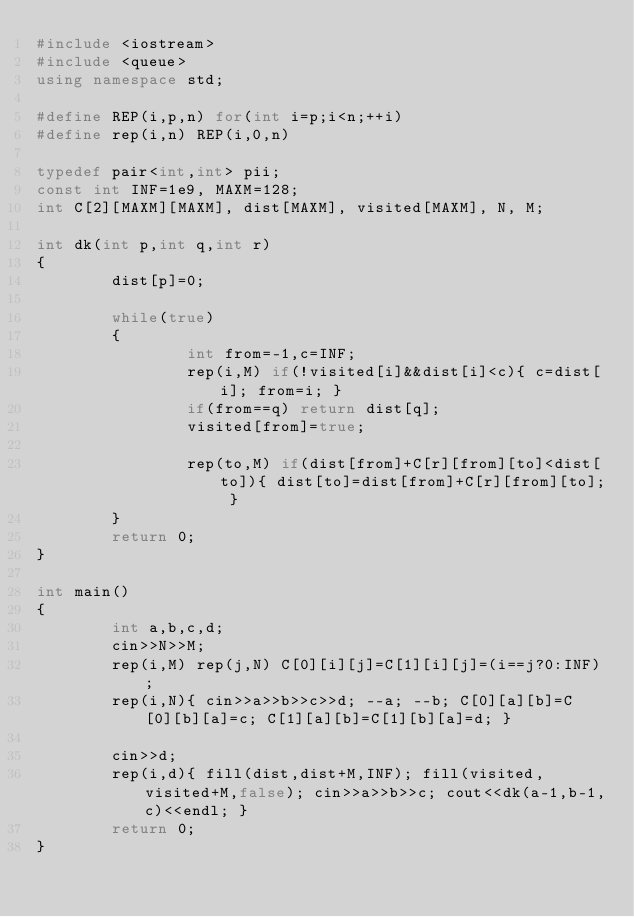<code> <loc_0><loc_0><loc_500><loc_500><_C++_>#include <iostream>
#include <queue>
using namespace std;

#define REP(i,p,n) for(int i=p;i<n;++i)
#define rep(i,n) REP(i,0,n)

typedef pair<int,int> pii;
const int INF=1e9, MAXM=128;
int C[2][MAXM][MAXM], dist[MAXM], visited[MAXM], N, M;

int dk(int p,int q,int r)
{
        dist[p]=0;

        while(true)
        {
                int from=-1,c=INF;
                rep(i,M) if(!visited[i]&&dist[i]<c){ c=dist[i]; from=i; }
                if(from==q) return dist[q];
                visited[from]=true;

                rep(to,M) if(dist[from]+C[r][from][to]<dist[to]){ dist[to]=dist[from]+C[r][from][to]; }
        }
        return 0;
}

int main()
{
        int a,b,c,d;
        cin>>N>>M;
        rep(i,M) rep(j,N) C[0][i][j]=C[1][i][j]=(i==j?0:INF);
        rep(i,N){ cin>>a>>b>>c>>d; --a; --b; C[0][a][b]=C[0][b][a]=c; C[1][a][b]=C[1][b][a]=d; }

        cin>>d;
        rep(i,d){ fill(dist,dist+M,INF); fill(visited,visited+M,false); cin>>a>>b>>c; cout<<dk(a-1,b-1,c)<<endl; }
        return 0;
}</code> 